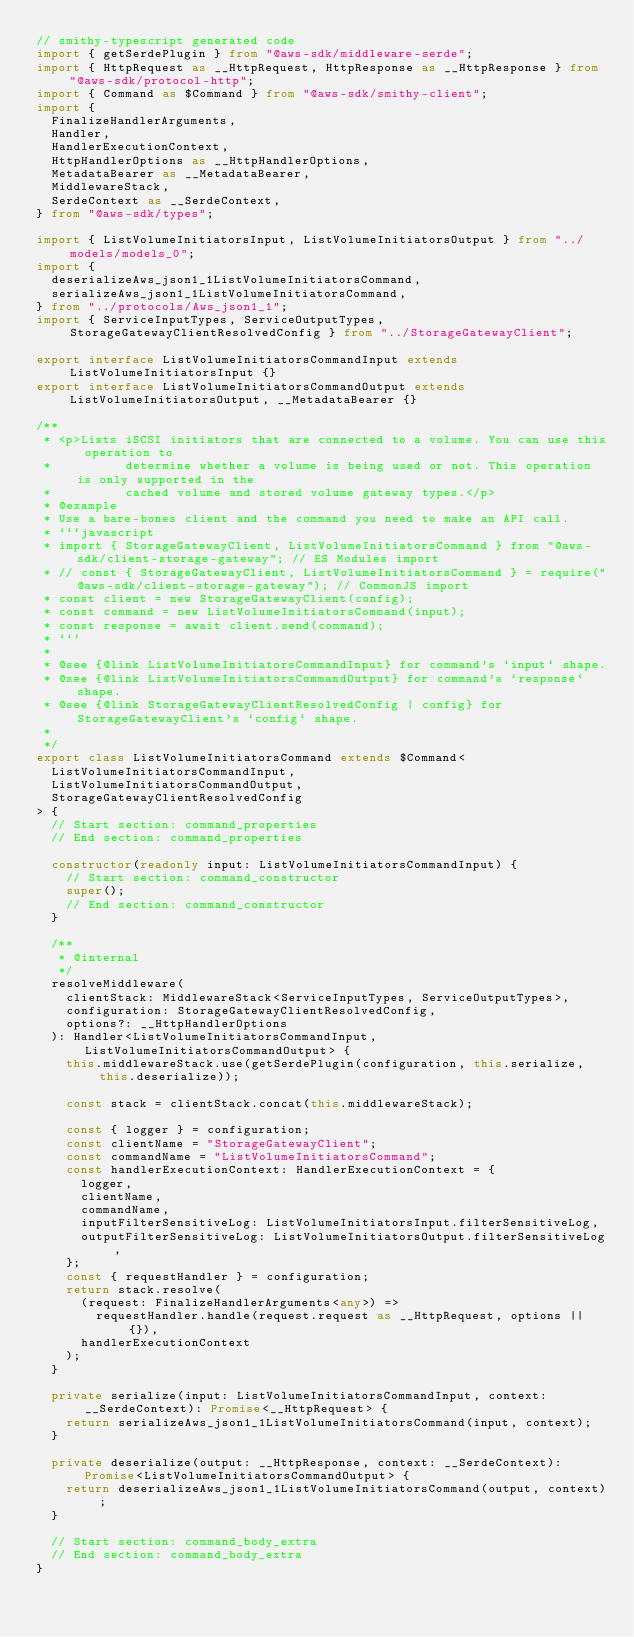Convert code to text. <code><loc_0><loc_0><loc_500><loc_500><_TypeScript_>// smithy-typescript generated code
import { getSerdePlugin } from "@aws-sdk/middleware-serde";
import { HttpRequest as __HttpRequest, HttpResponse as __HttpResponse } from "@aws-sdk/protocol-http";
import { Command as $Command } from "@aws-sdk/smithy-client";
import {
  FinalizeHandlerArguments,
  Handler,
  HandlerExecutionContext,
  HttpHandlerOptions as __HttpHandlerOptions,
  MetadataBearer as __MetadataBearer,
  MiddlewareStack,
  SerdeContext as __SerdeContext,
} from "@aws-sdk/types";

import { ListVolumeInitiatorsInput, ListVolumeInitiatorsOutput } from "../models/models_0";
import {
  deserializeAws_json1_1ListVolumeInitiatorsCommand,
  serializeAws_json1_1ListVolumeInitiatorsCommand,
} from "../protocols/Aws_json1_1";
import { ServiceInputTypes, ServiceOutputTypes, StorageGatewayClientResolvedConfig } from "../StorageGatewayClient";

export interface ListVolumeInitiatorsCommandInput extends ListVolumeInitiatorsInput {}
export interface ListVolumeInitiatorsCommandOutput extends ListVolumeInitiatorsOutput, __MetadataBearer {}

/**
 * <p>Lists iSCSI initiators that are connected to a volume. You can use this operation to
 *          determine whether a volume is being used or not. This operation is only supported in the
 *          cached volume and stored volume gateway types.</p>
 * @example
 * Use a bare-bones client and the command you need to make an API call.
 * ```javascript
 * import { StorageGatewayClient, ListVolumeInitiatorsCommand } from "@aws-sdk/client-storage-gateway"; // ES Modules import
 * // const { StorageGatewayClient, ListVolumeInitiatorsCommand } = require("@aws-sdk/client-storage-gateway"); // CommonJS import
 * const client = new StorageGatewayClient(config);
 * const command = new ListVolumeInitiatorsCommand(input);
 * const response = await client.send(command);
 * ```
 *
 * @see {@link ListVolumeInitiatorsCommandInput} for command's `input` shape.
 * @see {@link ListVolumeInitiatorsCommandOutput} for command's `response` shape.
 * @see {@link StorageGatewayClientResolvedConfig | config} for StorageGatewayClient's `config` shape.
 *
 */
export class ListVolumeInitiatorsCommand extends $Command<
  ListVolumeInitiatorsCommandInput,
  ListVolumeInitiatorsCommandOutput,
  StorageGatewayClientResolvedConfig
> {
  // Start section: command_properties
  // End section: command_properties

  constructor(readonly input: ListVolumeInitiatorsCommandInput) {
    // Start section: command_constructor
    super();
    // End section: command_constructor
  }

  /**
   * @internal
   */
  resolveMiddleware(
    clientStack: MiddlewareStack<ServiceInputTypes, ServiceOutputTypes>,
    configuration: StorageGatewayClientResolvedConfig,
    options?: __HttpHandlerOptions
  ): Handler<ListVolumeInitiatorsCommandInput, ListVolumeInitiatorsCommandOutput> {
    this.middlewareStack.use(getSerdePlugin(configuration, this.serialize, this.deserialize));

    const stack = clientStack.concat(this.middlewareStack);

    const { logger } = configuration;
    const clientName = "StorageGatewayClient";
    const commandName = "ListVolumeInitiatorsCommand";
    const handlerExecutionContext: HandlerExecutionContext = {
      logger,
      clientName,
      commandName,
      inputFilterSensitiveLog: ListVolumeInitiatorsInput.filterSensitiveLog,
      outputFilterSensitiveLog: ListVolumeInitiatorsOutput.filterSensitiveLog,
    };
    const { requestHandler } = configuration;
    return stack.resolve(
      (request: FinalizeHandlerArguments<any>) =>
        requestHandler.handle(request.request as __HttpRequest, options || {}),
      handlerExecutionContext
    );
  }

  private serialize(input: ListVolumeInitiatorsCommandInput, context: __SerdeContext): Promise<__HttpRequest> {
    return serializeAws_json1_1ListVolumeInitiatorsCommand(input, context);
  }

  private deserialize(output: __HttpResponse, context: __SerdeContext): Promise<ListVolumeInitiatorsCommandOutput> {
    return deserializeAws_json1_1ListVolumeInitiatorsCommand(output, context);
  }

  // Start section: command_body_extra
  // End section: command_body_extra
}
</code> 